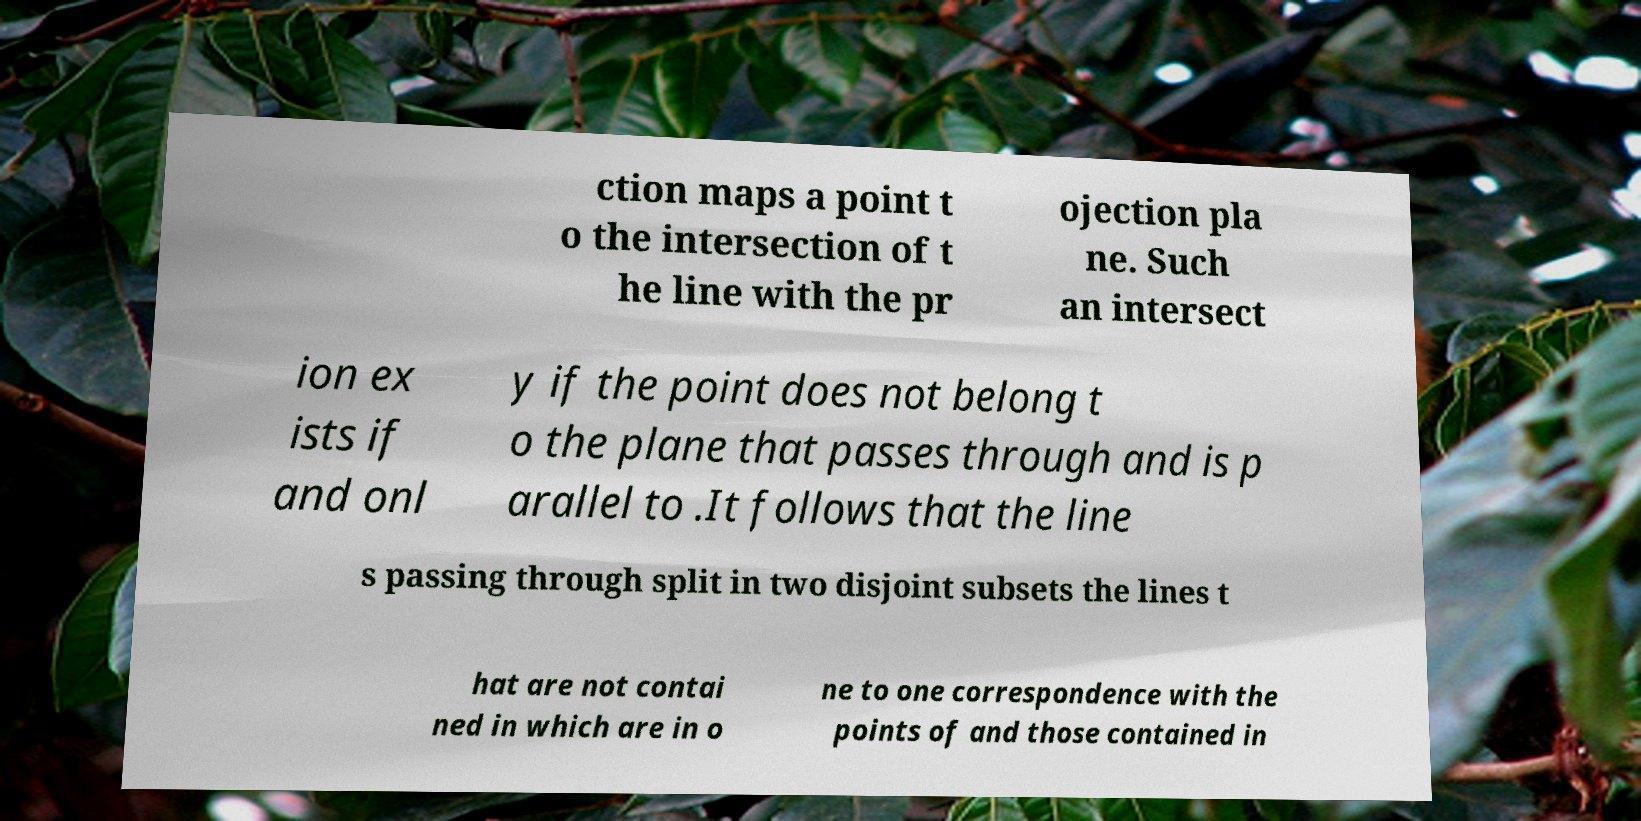Could you assist in decoding the text presented in this image and type it out clearly? ction maps a point t o the intersection of t he line with the pr ojection pla ne. Such an intersect ion ex ists if and onl y if the point does not belong t o the plane that passes through and is p arallel to .It follows that the line s passing through split in two disjoint subsets the lines t hat are not contai ned in which are in o ne to one correspondence with the points of and those contained in 